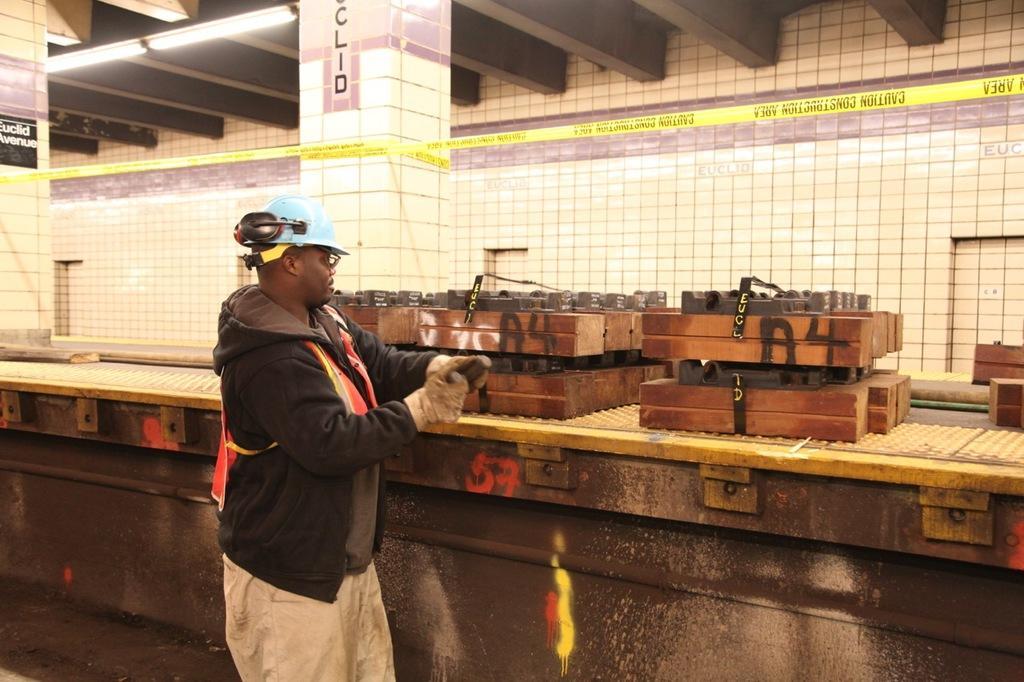Can you describe this image briefly? In this picture we can observe a man wearing black color hoodie and blue color helmet on his head. He is wearing gloves to his hands. We can observe a platform on which there are wooden boxes placed. We can observe two pillars and tube lights to the ceiling. In the background there is a wall. 